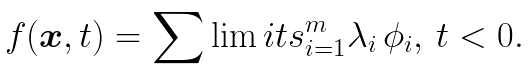<formula> <loc_0><loc_0><loc_500><loc_500>f ( { \boldsymbol x } , t ) = \sum \lim i t s _ { i = 1 } ^ { m } \lambda _ { i } \, \phi _ { i } , \, t < 0 .</formula> 